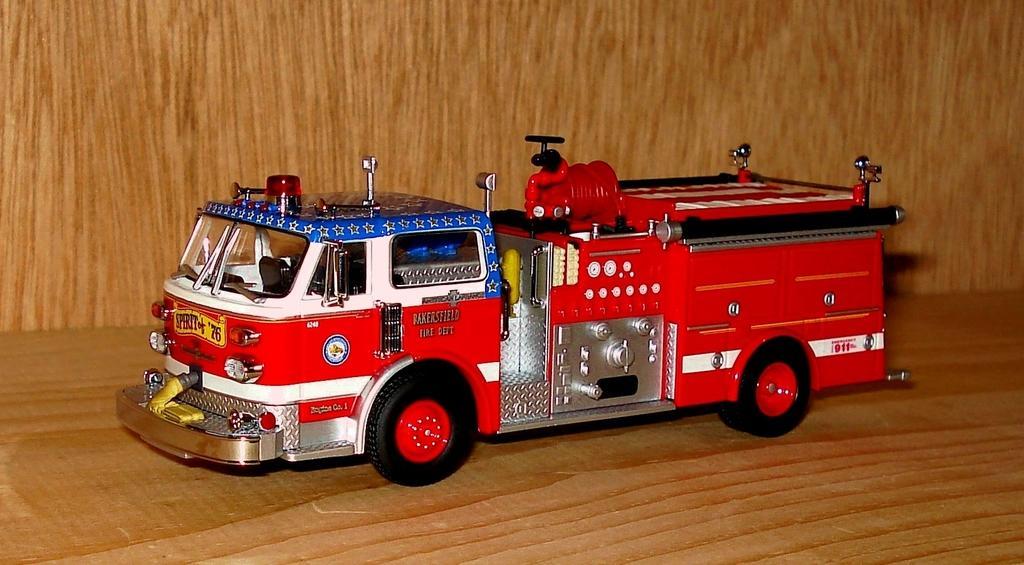What type of toy is in the image? There is a toy fire engine in the image. What is the toy fire engine placed on? The toy fire engine is on a wooden surface. What can be seen in the background of the image? There is a wooden wall in the background of the image. What type of patch can be seen on the fire engine in the image? There is no patch visible on the toy fire engine in the image. 